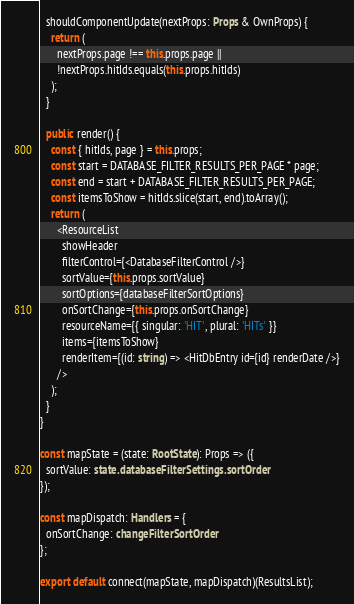Convert code to text. <code><loc_0><loc_0><loc_500><loc_500><_TypeScript_>  shouldComponentUpdate(nextProps: Props & OwnProps) {
    return (
      nextProps.page !== this.props.page ||
      !nextProps.hitIds.equals(this.props.hitIds)
    );
  }

  public render() {
    const { hitIds, page } = this.props;
    const start = DATABASE_FILTER_RESULTS_PER_PAGE * page;
    const end = start + DATABASE_FILTER_RESULTS_PER_PAGE;
    const itemsToShow = hitIds.slice(start, end).toArray();
    return (
      <ResourceList
        showHeader
        filterControl={<DatabaseFilterControl />}
        sortValue={this.props.sortValue}
        sortOptions={databaseFilterSortOptions}
        onSortChange={this.props.onSortChange}
        resourceName={{ singular: 'HIT', plural: 'HITs' }}
        items={itemsToShow}
        renderItem={(id: string) => <HitDbEntry id={id} renderDate />}
      />
    );
  }
}

const mapState = (state: RootState): Props => ({
  sortValue: state.databaseFilterSettings.sortOrder
});

const mapDispatch: Handlers = {
  onSortChange: changeFilterSortOrder
};

export default connect(mapState, mapDispatch)(ResultsList);
</code> 